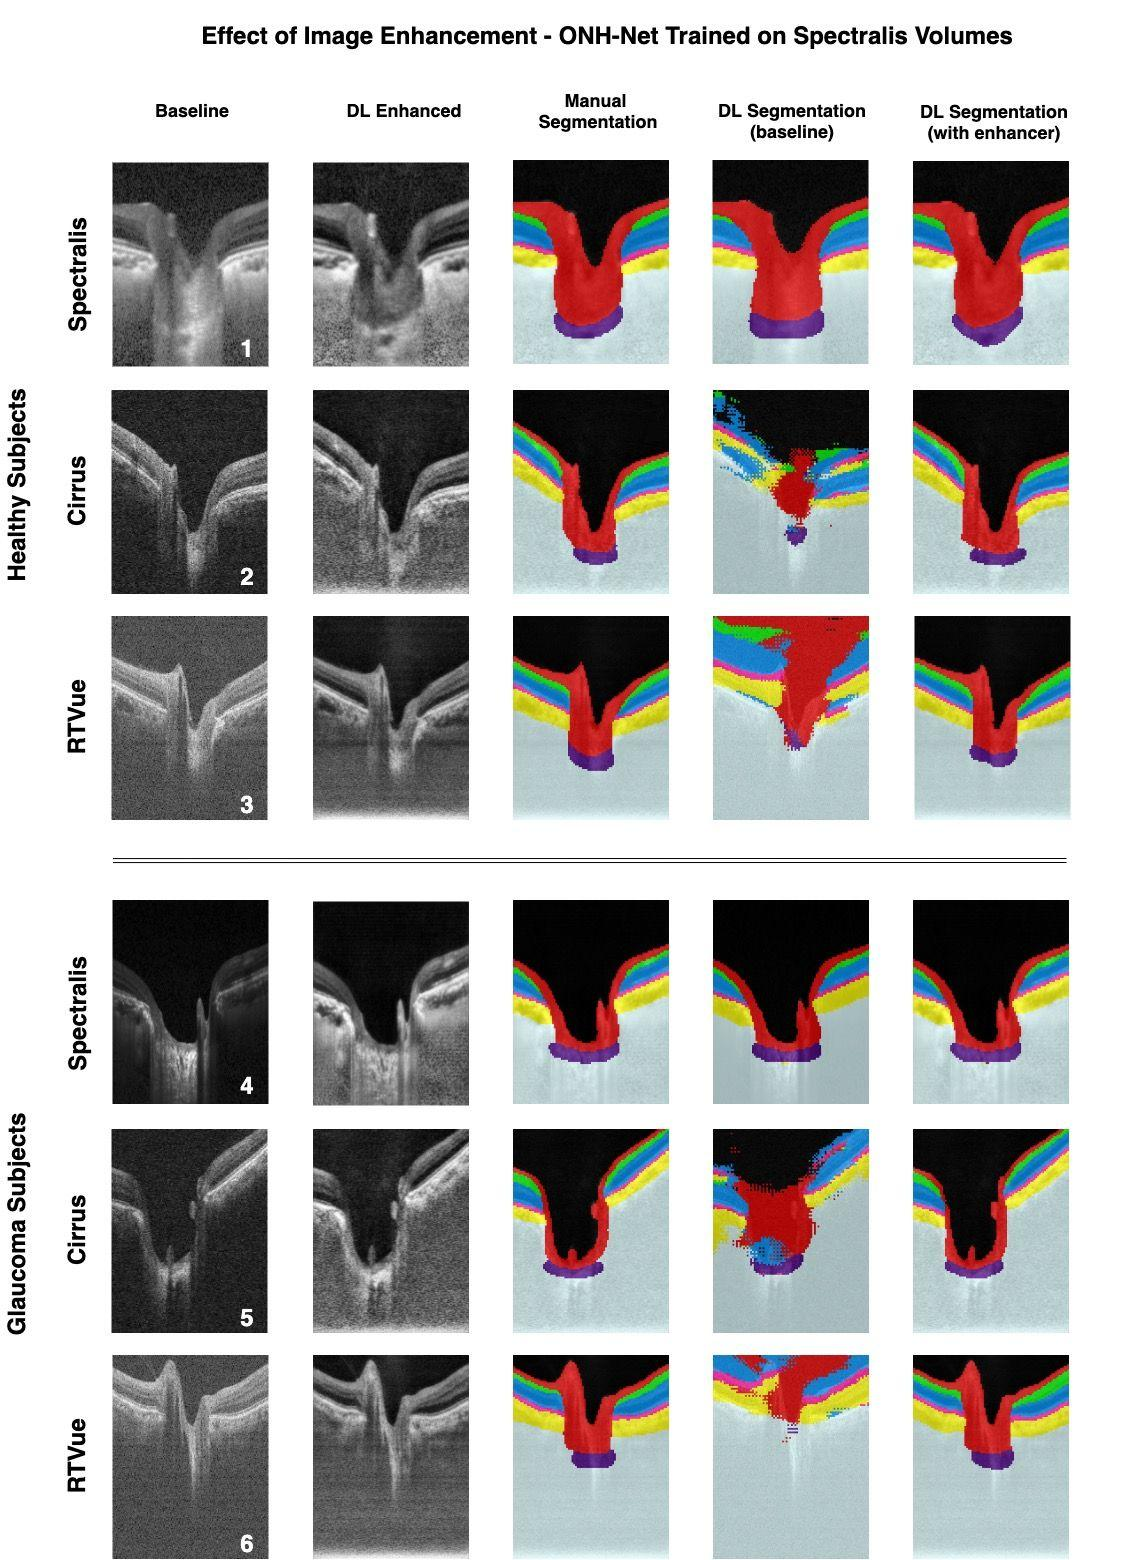What is the main purpose of the image enhancement technique as applied to the optical coherence tomography (OCT) images in this figure? A) To decrease the image resolution for faster processing B) To improve the visibility of the retinal layers for better segmentation C) To change the color scheme of the OCT images for aesthetic purposes D) To increase the noise in the images to test the robustness of the segmentation algorithms The figure shows a comparison between baseline OCT images and those that have been enhanced using deep learning (DL) techniques. The purpose of image enhancement is to make certain features more visible, which in this case are the retinal layers that are more clearly delineated after enhancement, aiding in better segmentation as shown in the corresponding columns. Therefore, the correct answer is B. 